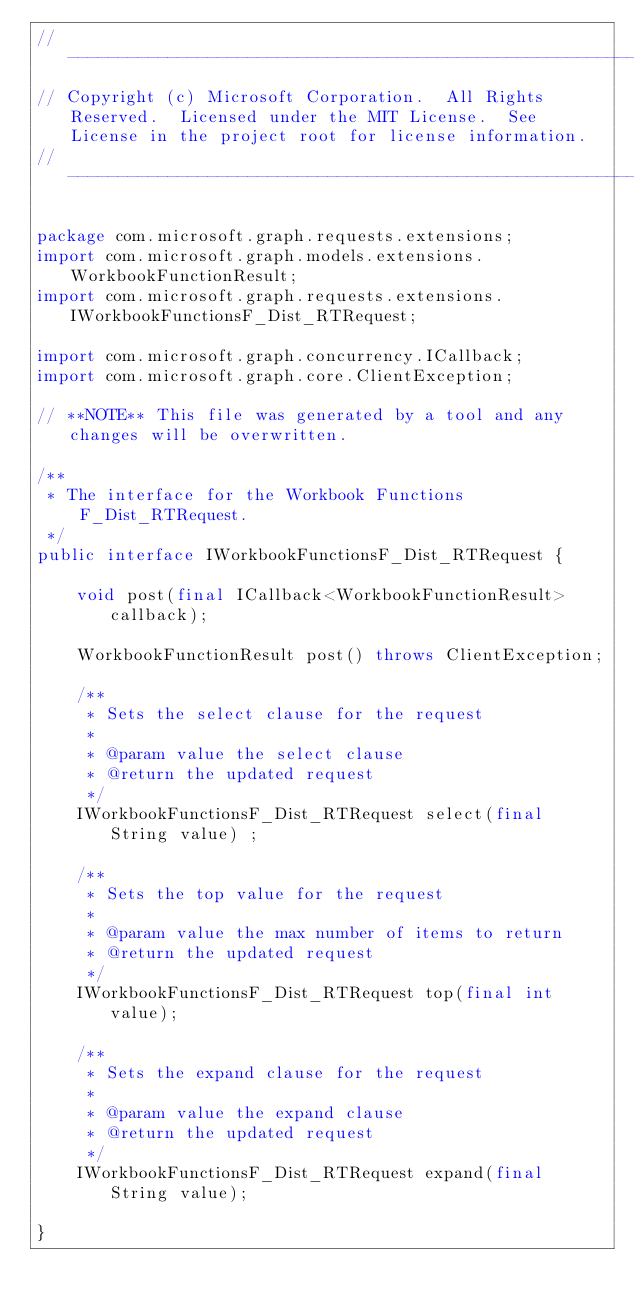<code> <loc_0><loc_0><loc_500><loc_500><_Java_>// ------------------------------------------------------------------------------
// Copyright (c) Microsoft Corporation.  All Rights Reserved.  Licensed under the MIT License.  See License in the project root for license information.
// ------------------------------------------------------------------------------

package com.microsoft.graph.requests.extensions;
import com.microsoft.graph.models.extensions.WorkbookFunctionResult;
import com.microsoft.graph.requests.extensions.IWorkbookFunctionsF_Dist_RTRequest;

import com.microsoft.graph.concurrency.ICallback;
import com.microsoft.graph.core.ClientException;

// **NOTE** This file was generated by a tool and any changes will be overwritten.

/**
 * The interface for the Workbook Functions F_Dist_RTRequest.
 */
public interface IWorkbookFunctionsF_Dist_RTRequest {

    void post(final ICallback<WorkbookFunctionResult> callback);

    WorkbookFunctionResult post() throws ClientException;

    /**
     * Sets the select clause for the request
     *
     * @param value the select clause
     * @return the updated request
     */
    IWorkbookFunctionsF_Dist_RTRequest select(final String value) ;

    /**
     * Sets the top value for the request
     *
     * @param value the max number of items to return
     * @return the updated request
     */
    IWorkbookFunctionsF_Dist_RTRequest top(final int value);

    /**
     * Sets the expand clause for the request
     *
     * @param value the expand clause
     * @return the updated request
     */
    IWorkbookFunctionsF_Dist_RTRequest expand(final String value);

}
</code> 